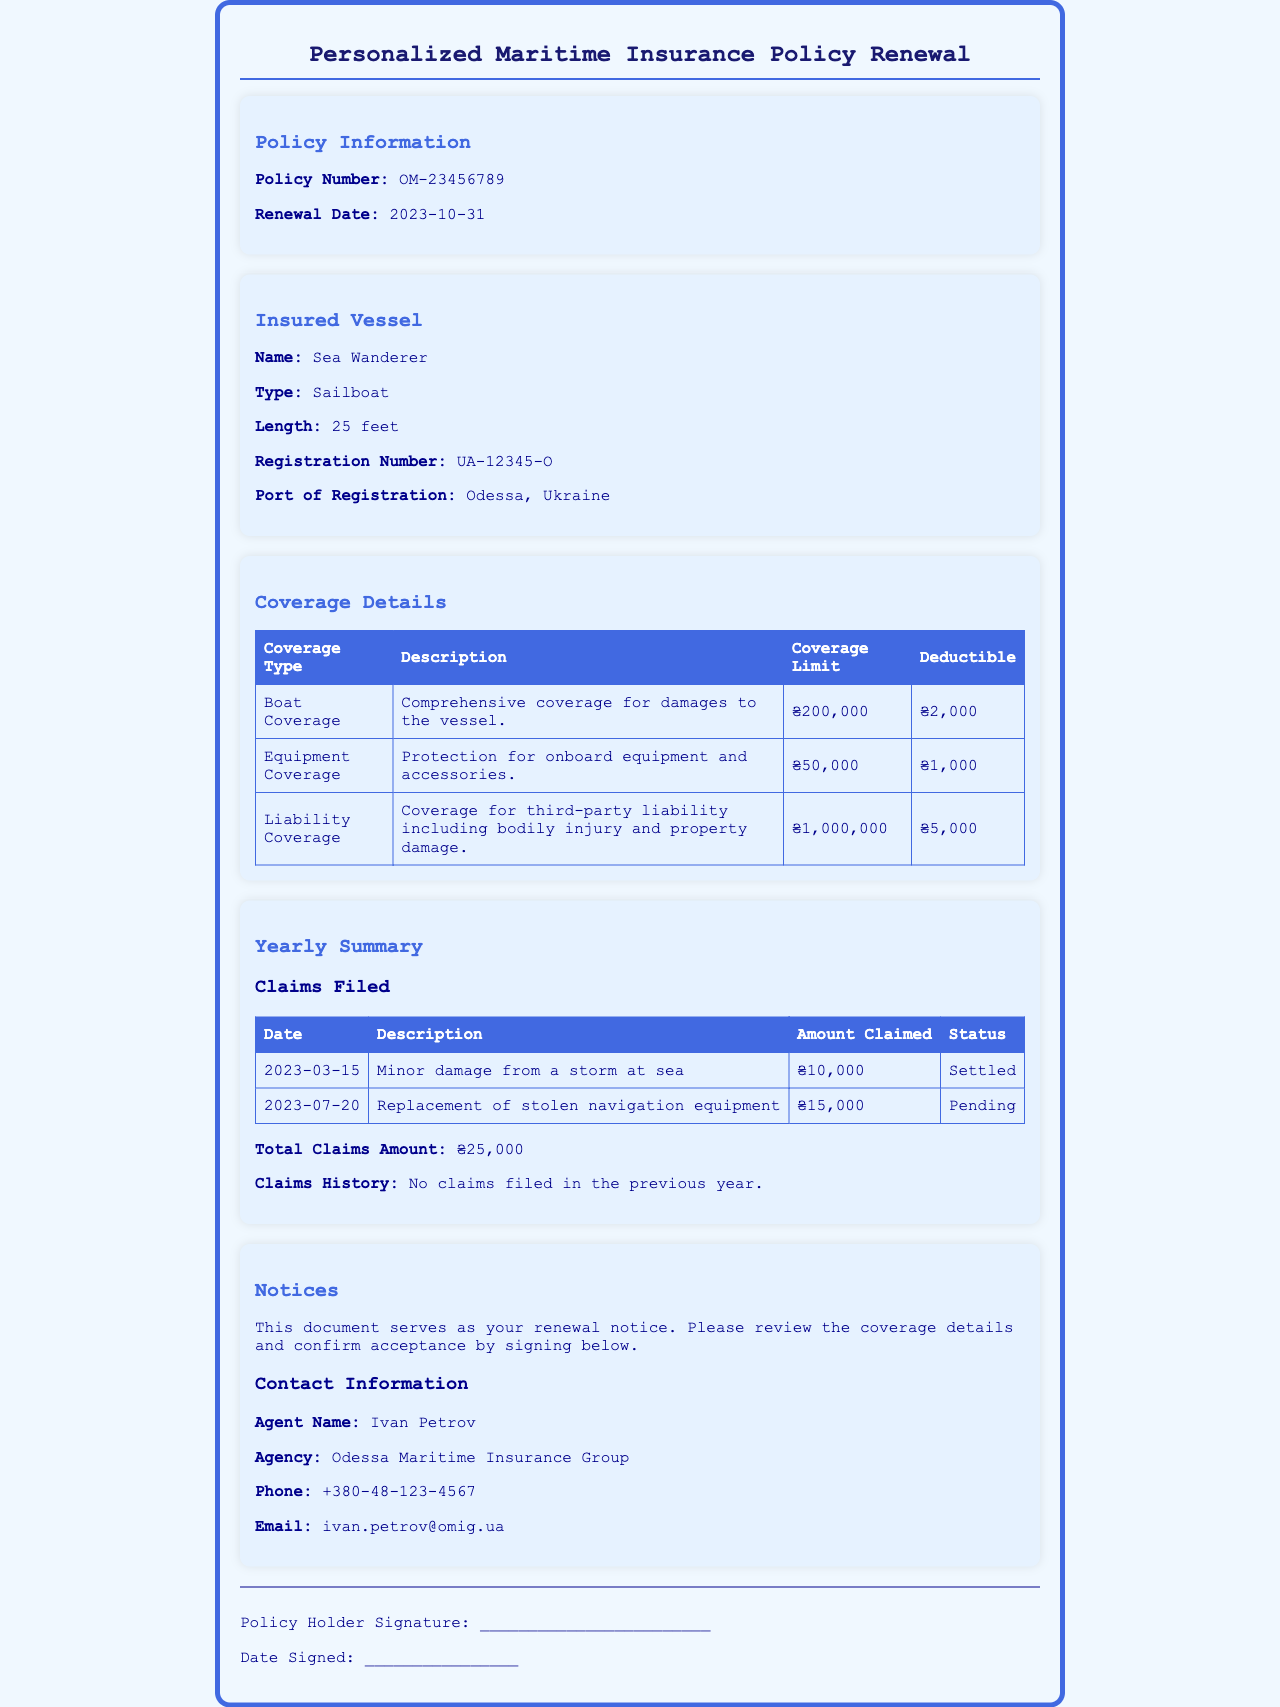What is the policy number? The policy number is listed in the Policy Information section of the document.
Answer: OM-23456789 What is the renewal date? The renewal date is provided in the Policy Information section.
Answer: 2023-10-31 What is the name of the insured vessel? The insured vessel's name is mentioned under the Insured Vessel section.
Answer: Sea Wanderer What is the coverage limit for liability coverage? The coverage limit for liability coverage is found in the Coverage Details table.
Answer: ₴1,000,000 What was the amount claimed for the minor damage? The amount claimed for the minor damage is specified in the Yearly Summary section.
Answer: ₴10,000 What is the status of the claim for stolen equipment? The status of this claim is indicated in the Claims Filed table.
Answer: Pending How many claims were filed in the previous year? The document states the claims history in the Yearly Summary section, which details claims filed in the past year.
Answer: No claims filed Who is the agent for this insurance policy? The agent's name is provided in the Contact Information section.
Answer: Ivan Petrov What type of vessel is insured under this policy? The type of the insured vessel is specified in the Insured Vessel section of the document.
Answer: Sailboat 